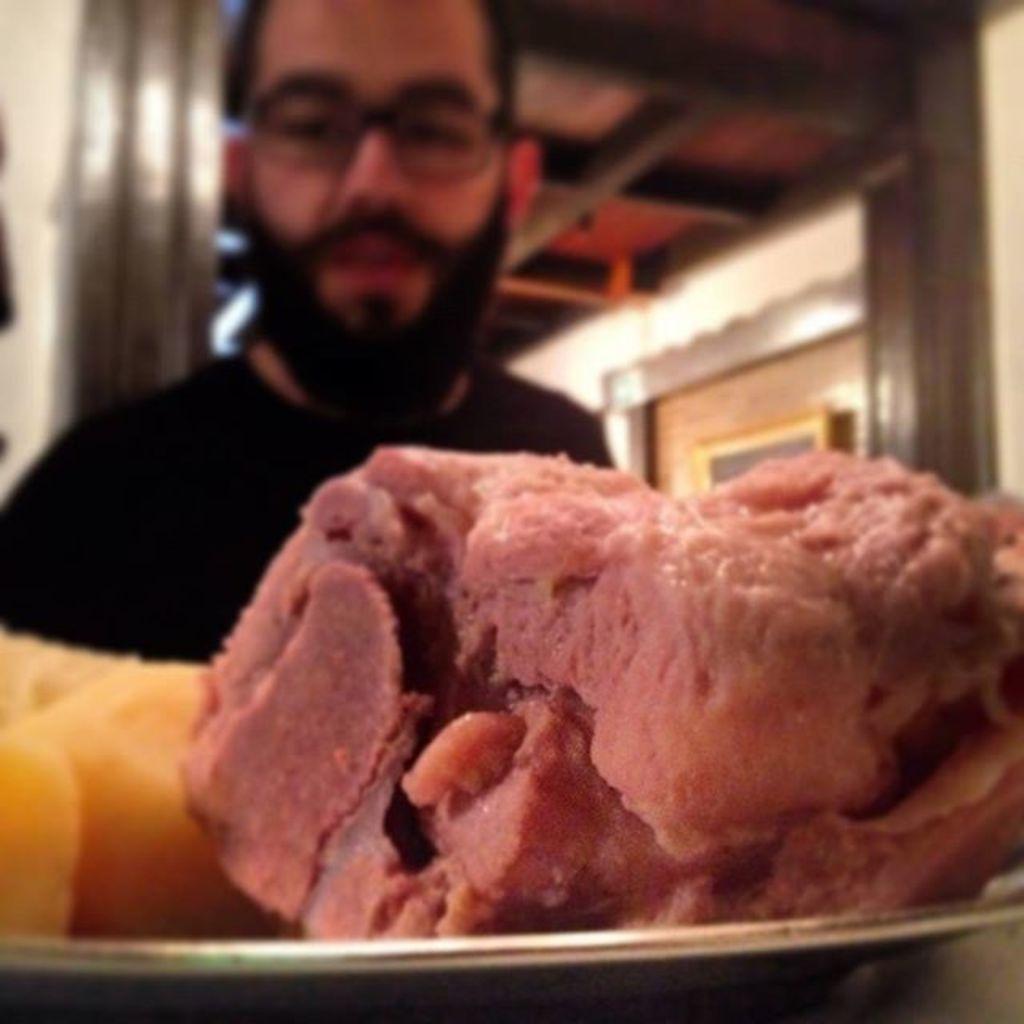Could you give a brief overview of what you see in this image? In this picture I can observe some food in the plate. The plate is placed on the table. I can observe a man wearing black color T shirt and spectacles. In the background I can observe a door. 